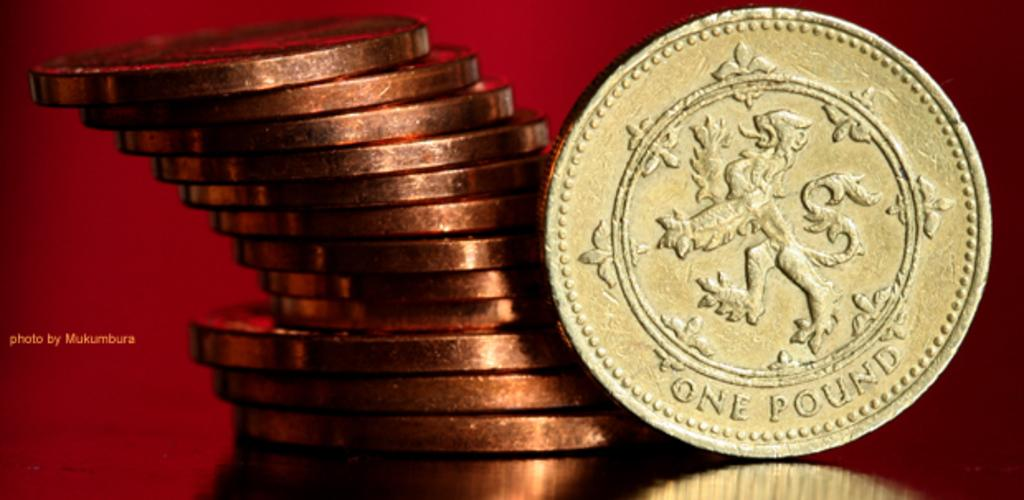Provide a one-sentence caption for the provided image. A stack of gold colored coins with one laying on its side that says One Pound. 